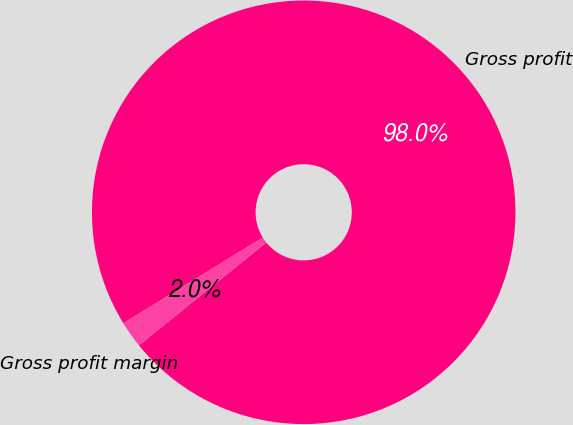<chart> <loc_0><loc_0><loc_500><loc_500><pie_chart><fcel>Gross profit<fcel>Gross profit margin<nl><fcel>97.97%<fcel>2.03%<nl></chart> 